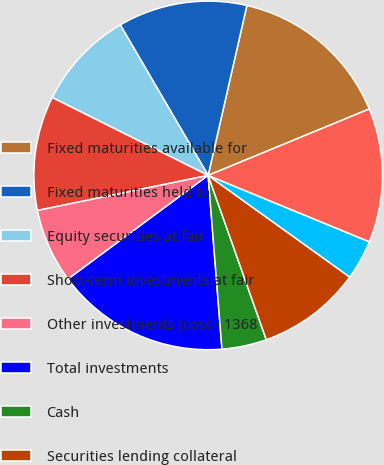Convert chart to OTSL. <chart><loc_0><loc_0><loc_500><loc_500><pie_chart><fcel>Fixed maturities available for<fcel>Fixed maturities held to<fcel>Equity securities at fair<fcel>Short-term investments at fair<fcel>Other investments (cost - 1368<fcel>Total investments<fcel>Cash<fcel>Securities lending collateral<fcel>Accrued investment income<fcel>Insurance and reinsurance<nl><fcel>15.21%<fcel>11.98%<fcel>9.22%<fcel>10.6%<fcel>6.91%<fcel>16.13%<fcel>4.15%<fcel>9.68%<fcel>3.69%<fcel>12.44%<nl></chart> 